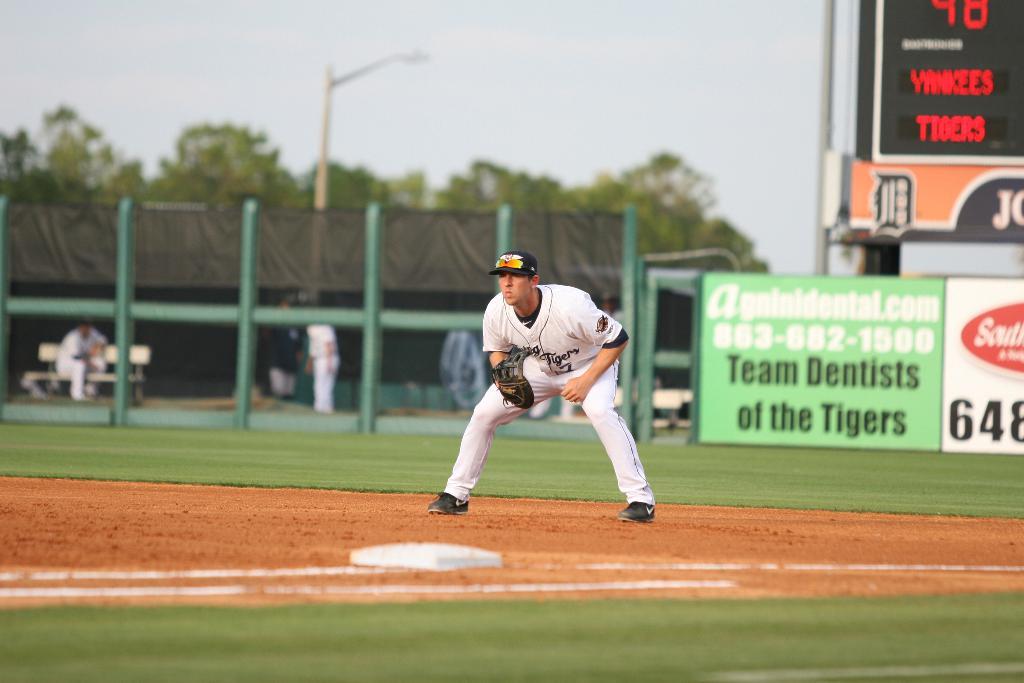Who are the tigers playing on the score board?
Provide a succinct answer. Yankees. What kind of medical office does the green sign advertise?
Your response must be concise. Dentist. 